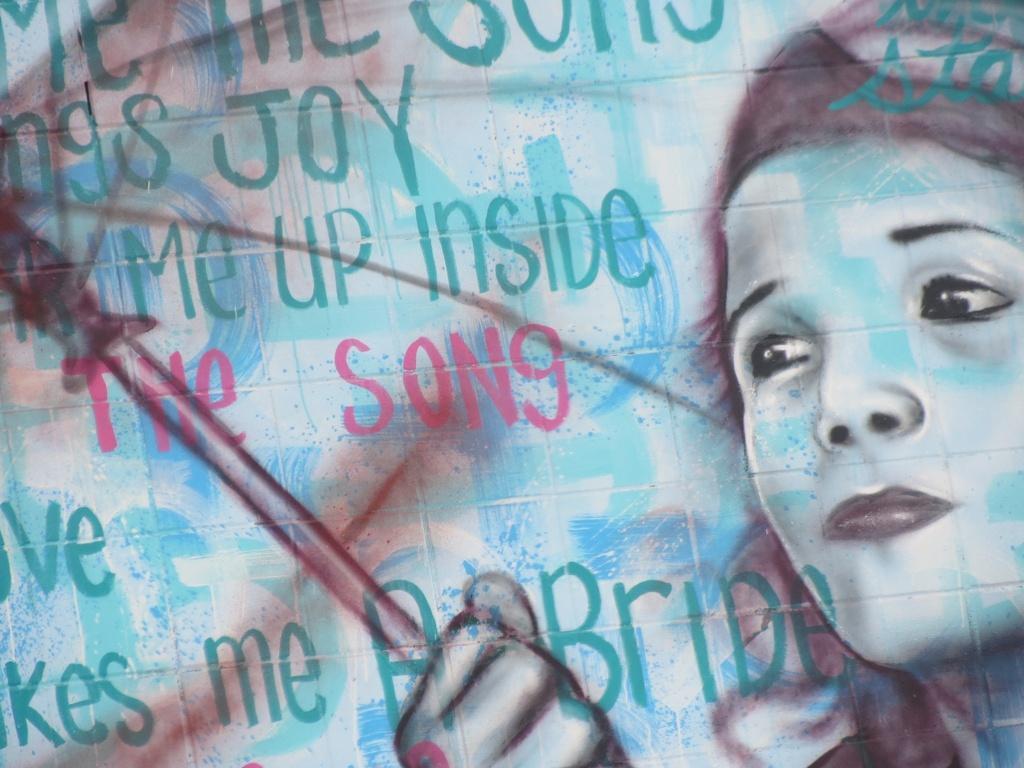Describe this image in one or two sentences. On the right of this picture we can see the sketch of a person holding some object. On the left we can see the text. 